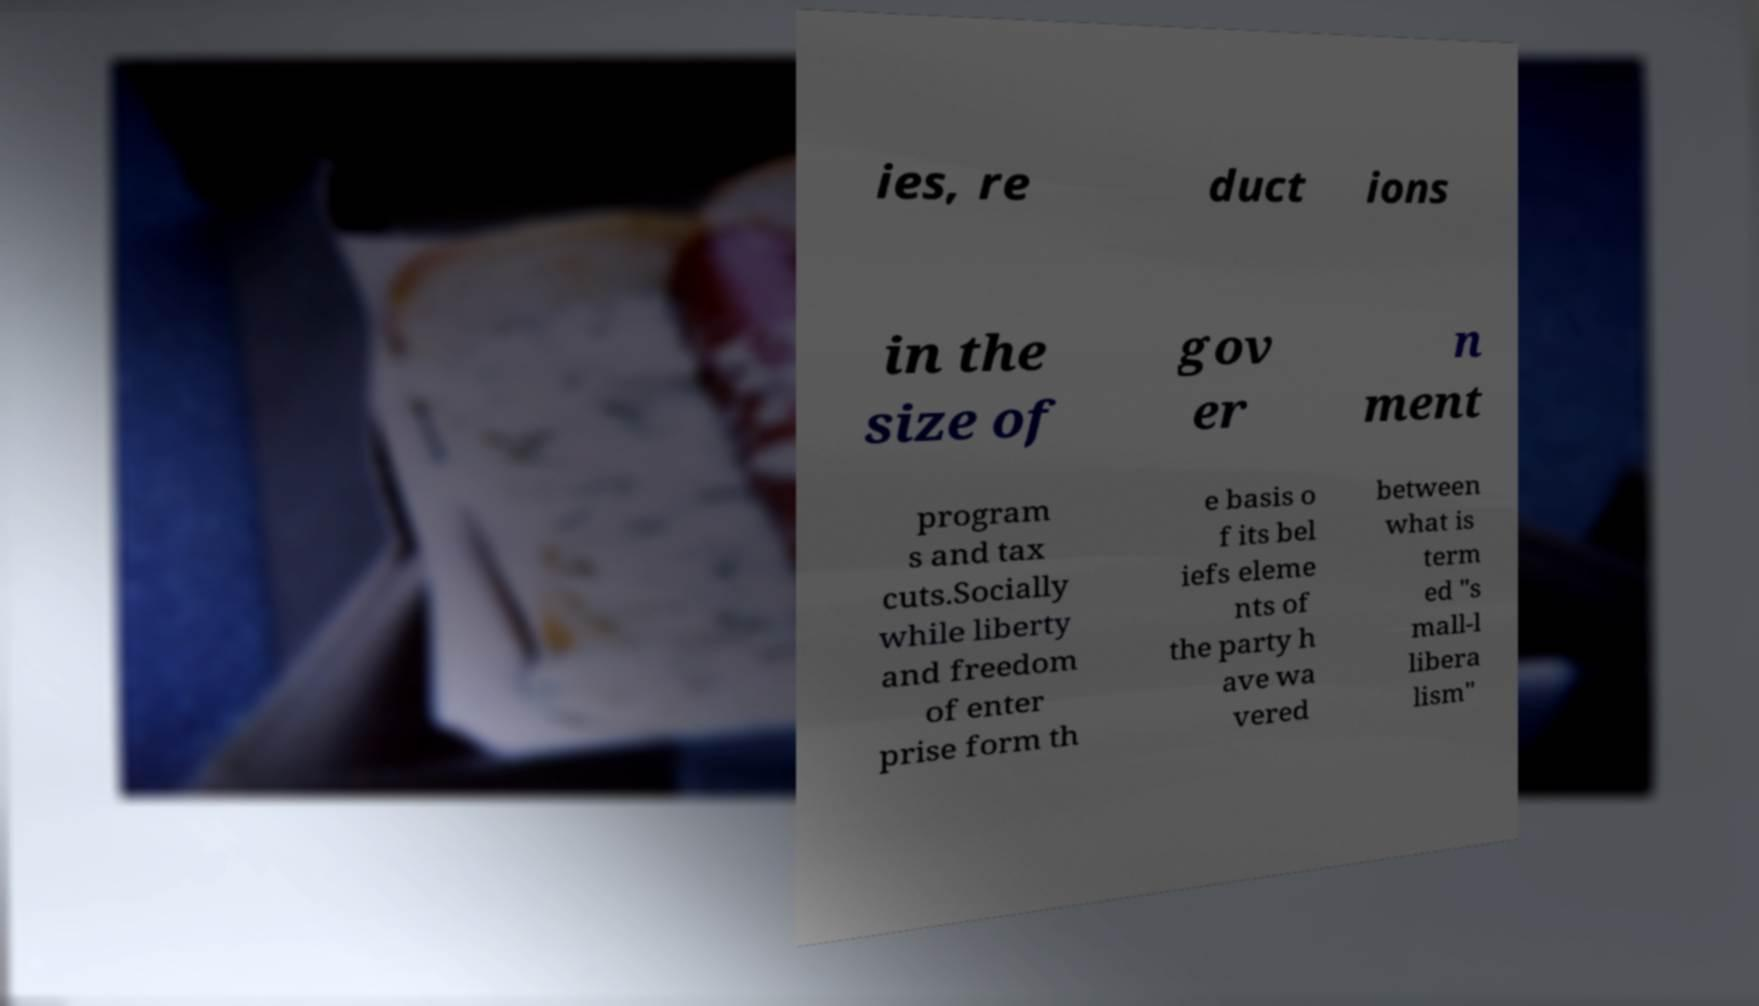What messages or text are displayed in this image? I need them in a readable, typed format. ies, re duct ions in the size of gov er n ment program s and tax cuts.Socially while liberty and freedom of enter prise form th e basis o f its bel iefs eleme nts of the party h ave wa vered between what is term ed "s mall-l libera lism" 